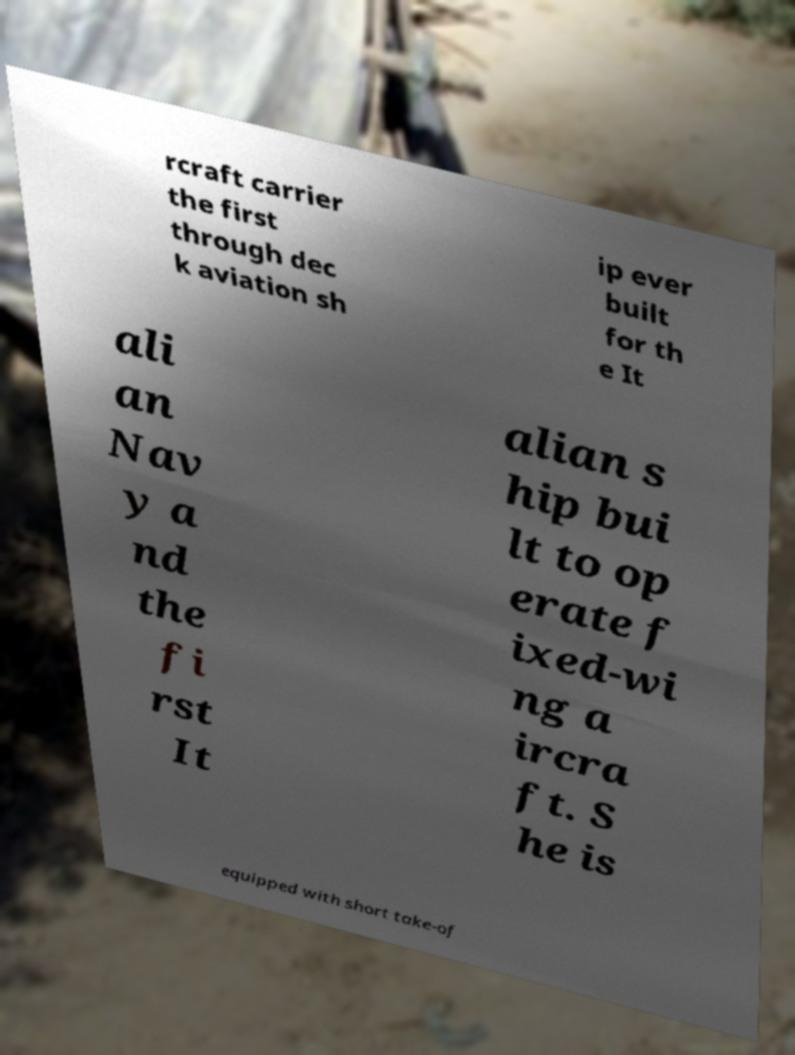There's text embedded in this image that I need extracted. Can you transcribe it verbatim? rcraft carrier the first through dec k aviation sh ip ever built for th e It ali an Nav y a nd the fi rst It alian s hip bui lt to op erate f ixed-wi ng a ircra ft. S he is equipped with short take-of 